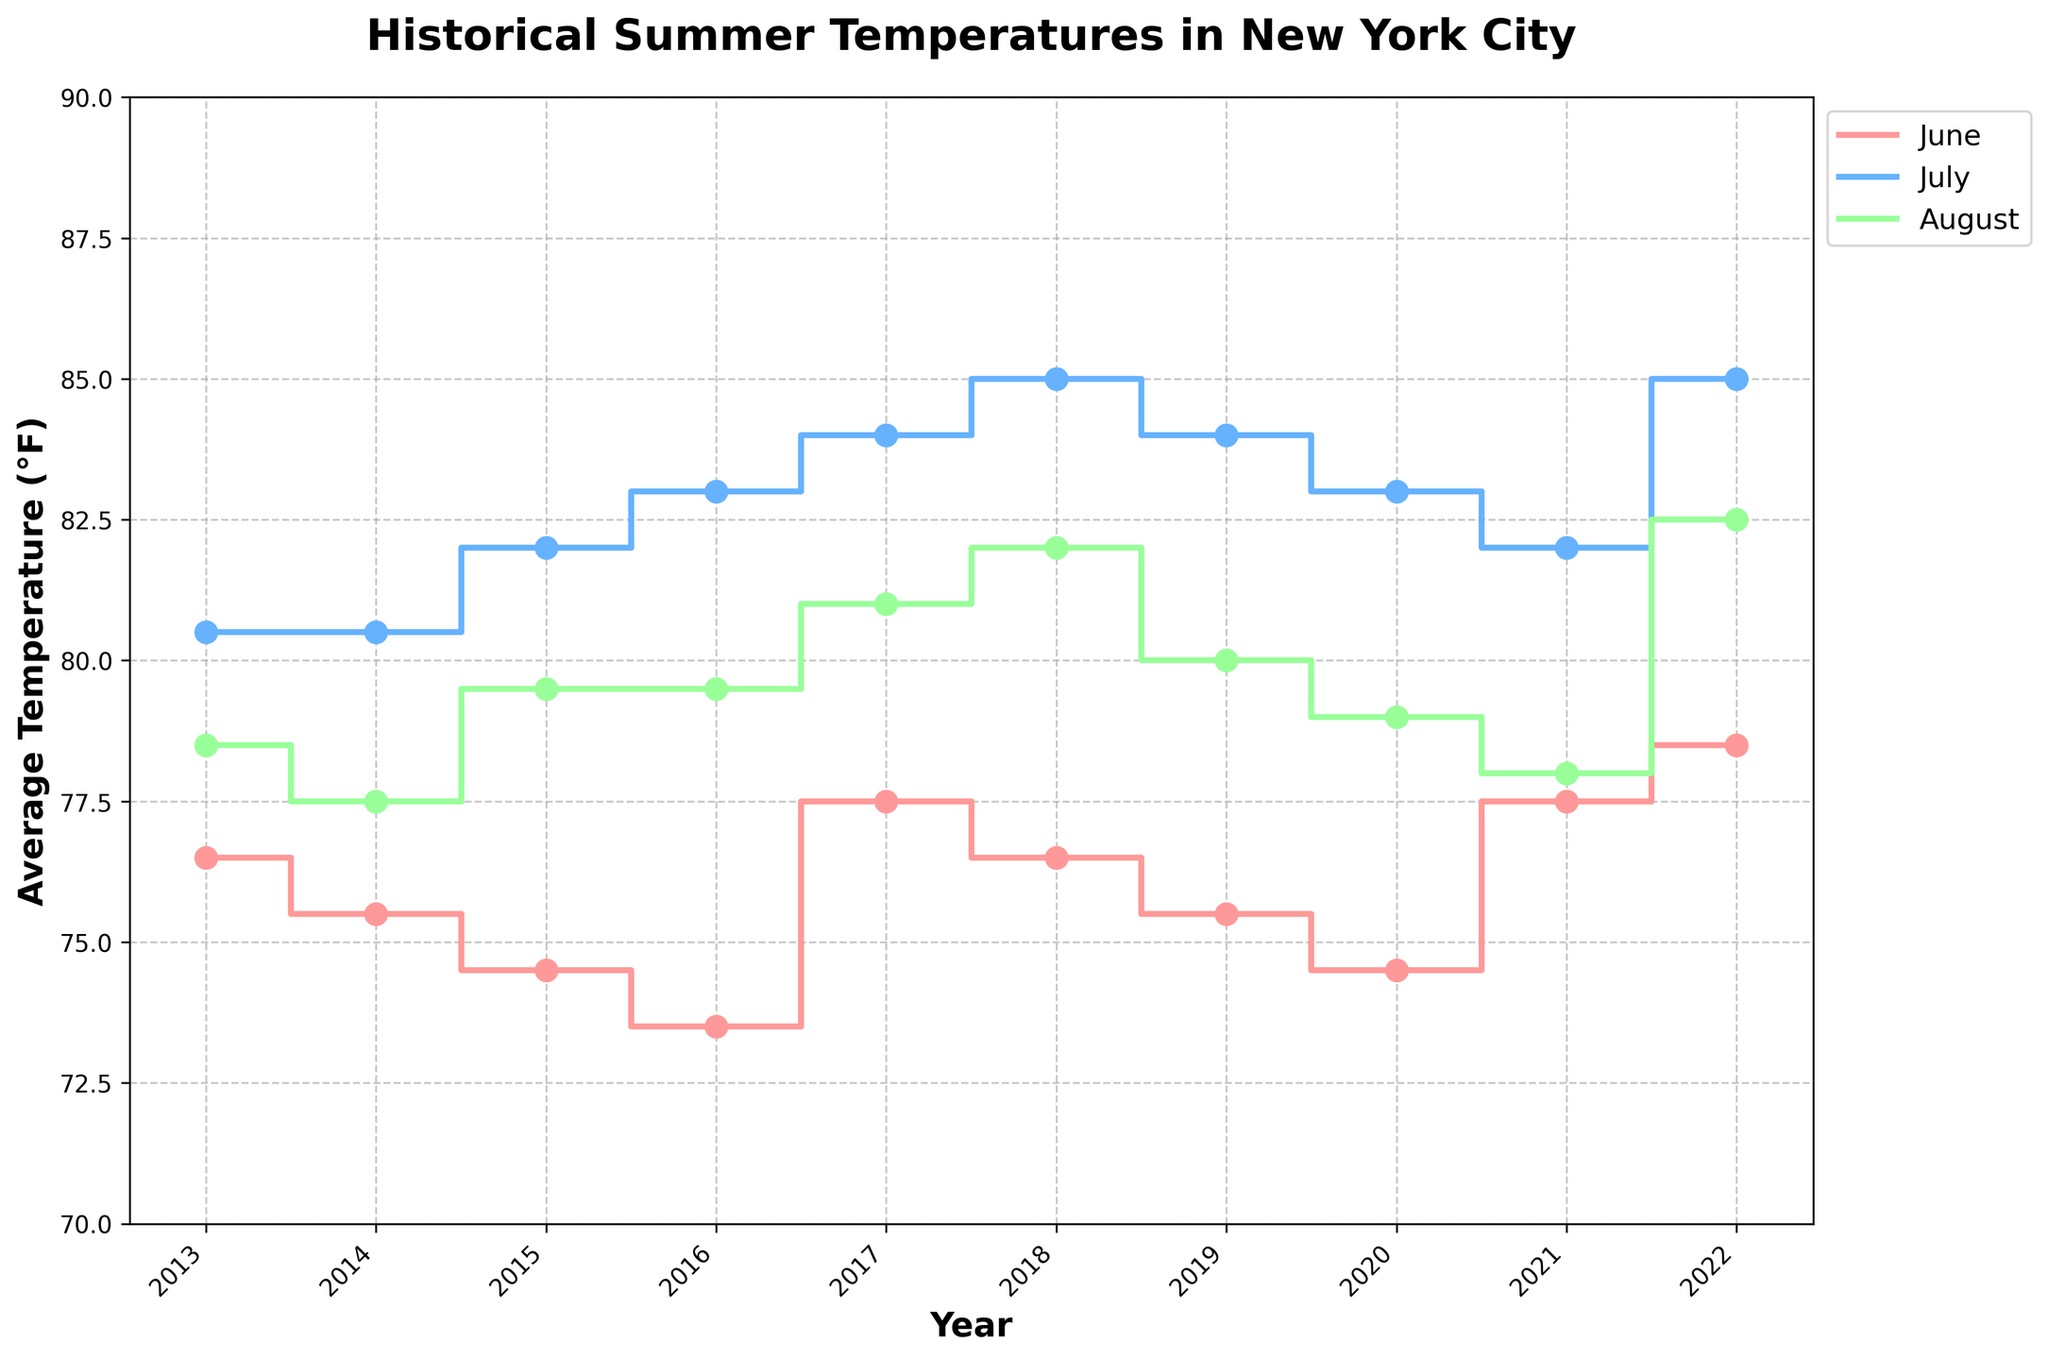What is the title of the figure? The title of the figure can be found at the top of the plot. It is usually in bold and larger font compared to other text in the plot.
Answer: Historical Summer Temperatures in New York City How is the x-axis labeled? The label of the x-axis is usually found along the horizontal axis of the plot. It describes what the axis represents.
Answer: Year What months are represented by different colors on the plot? The months are differentiated by colors. The legend at the top right corner of the plot maps these colors to specific months.
Answer: June, July, August Which year had the highest average temperature in July? To find the highest average temperature in July, look for the peak data point in the July series, which can be identified by steps and markers in a specific color.
Answer: 2018 and 2022 Between 2013 and 2022, which month showed the most noticeable increase in average temperature? Identify the months by their respective colors, and observe the changes in the plot for each year. Compare the steps for each month over time to determine which has the largest increase in average temperature.
Answer: July What was the average temperature in August 2018? Locate the data point for August 2018 on the plot and read the temperature value directly.
Answer: 82.0°F Compare the average temperatures in July between 2015 and 2018. Which year was hotter and by how much? Locate the data points for July in 2015 and 2018 and compare their values. Subtract the earlier year's temperature from the later year's temperature to find the difference.
Answer: 2018 was hotter by 3.0°F What is the overall trend in average temperatures for the month of June from 2013 to 2022? Observe the series representing June, following its steps from the start year to the end year. Determine if the temperatures generally rise, decline, or stay stable.
Answer: Gradually increasing Which month, according to the figure, had the most stable average temperatures over the given period? To determine stability, look for the month with the least variation in steps over the years, indicated by slight or small changes in temperature values.
Answer: June How do the average temperatures in August 2022 compare to those in August 2013? Locate the August data points for the years 2022 and 2013 and compare their values. Note if one is higher, and state the difference.
Answer: 2022 was 4°F hotter than 2013 